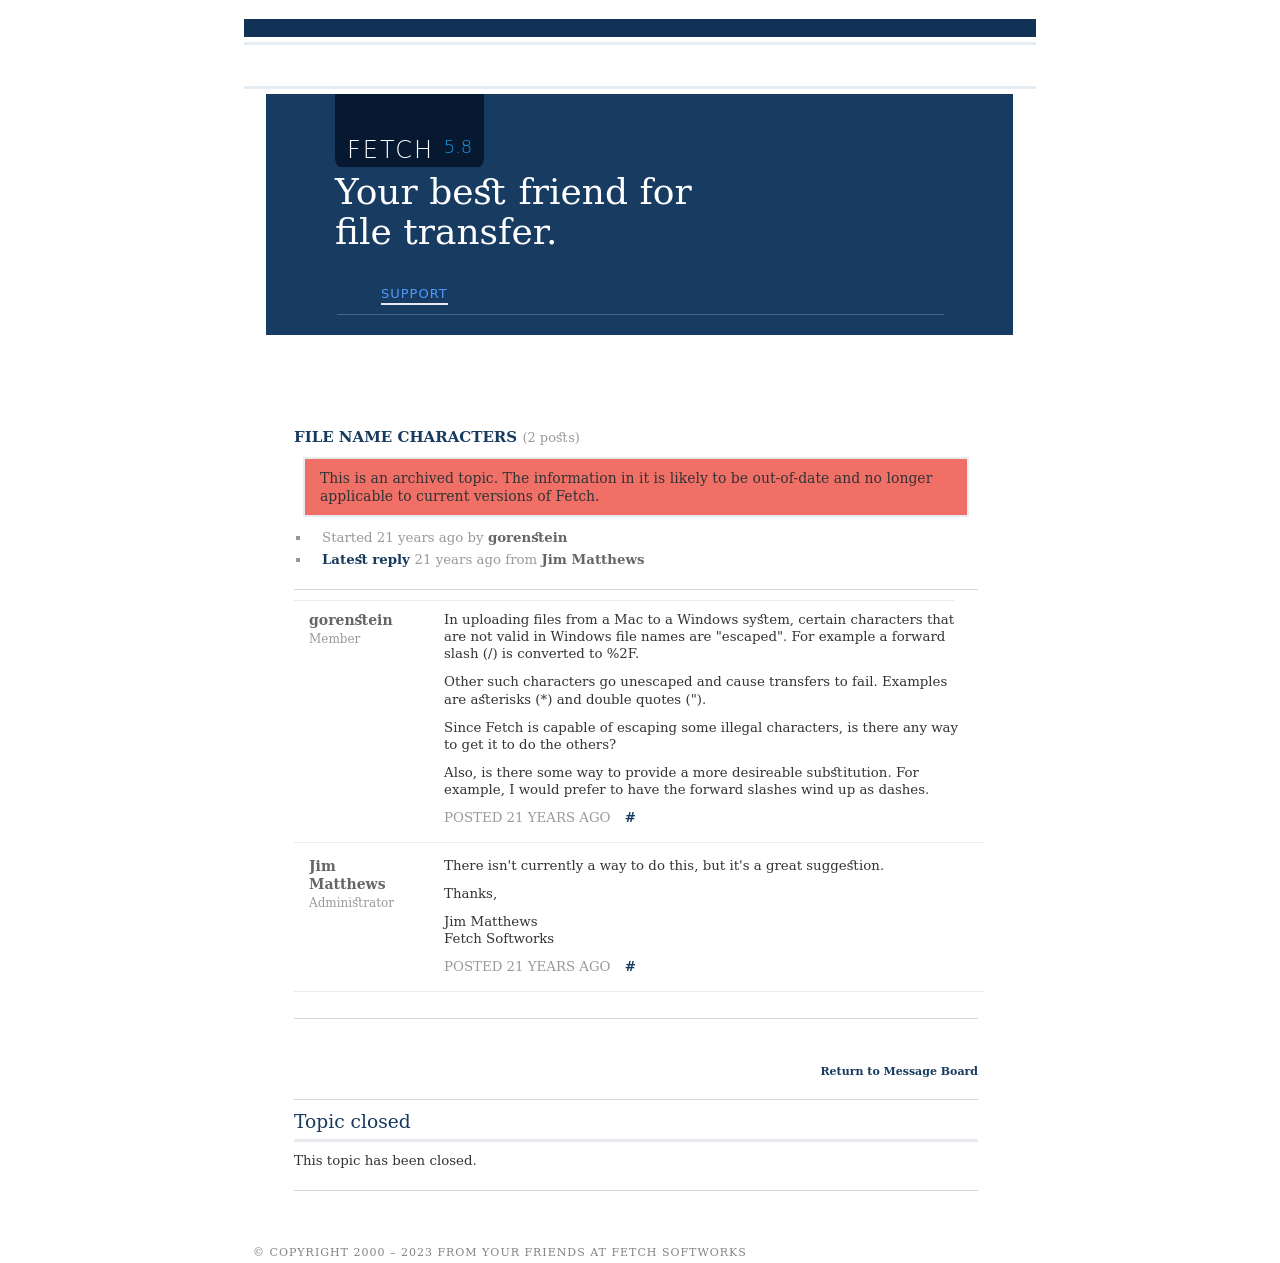What are some of the potential challenges in modernizing the interface of an archived software forum site like shown in the image? Modernizing an archived software forum such as the one shown could involve several challenges. Firstly, ensuring that the system accommodates modern security standards would be crucial to protect user data. Additionally, improving accessibility by adhering to current web standards could help in reaching a broader audience. Integrating responsive design to ensure compatibility with various devices, from smartphones to desktops, is also essential. Lastly, incorporating newer technologies for better user engagement like real-time notifications or interactive elements could be explored to enhance the user experience. 